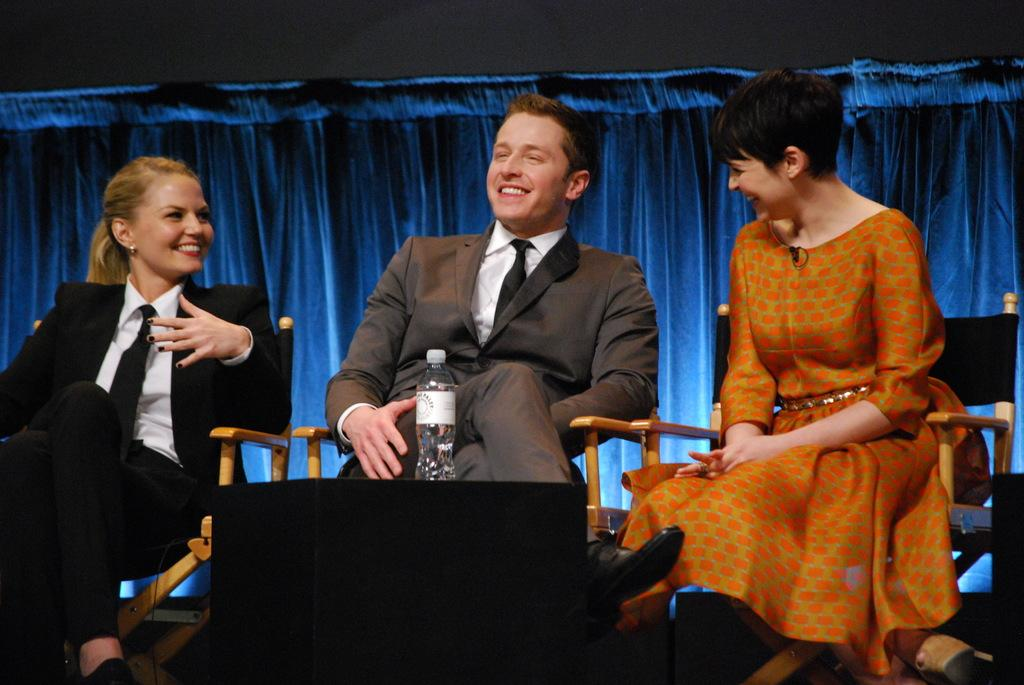What are the people in the image doing? The people in the image are sitting on chairs. What object can be seen besides the people and chairs? There is a bottle visible in the image. What color is the cloth in the background of the image? The cloth in the background of the image is blue. How many tickets are being handed out in the image? There are no tickets present in the image. What type of order is being taken in the image? There is no indication of an order being taken in the image. 